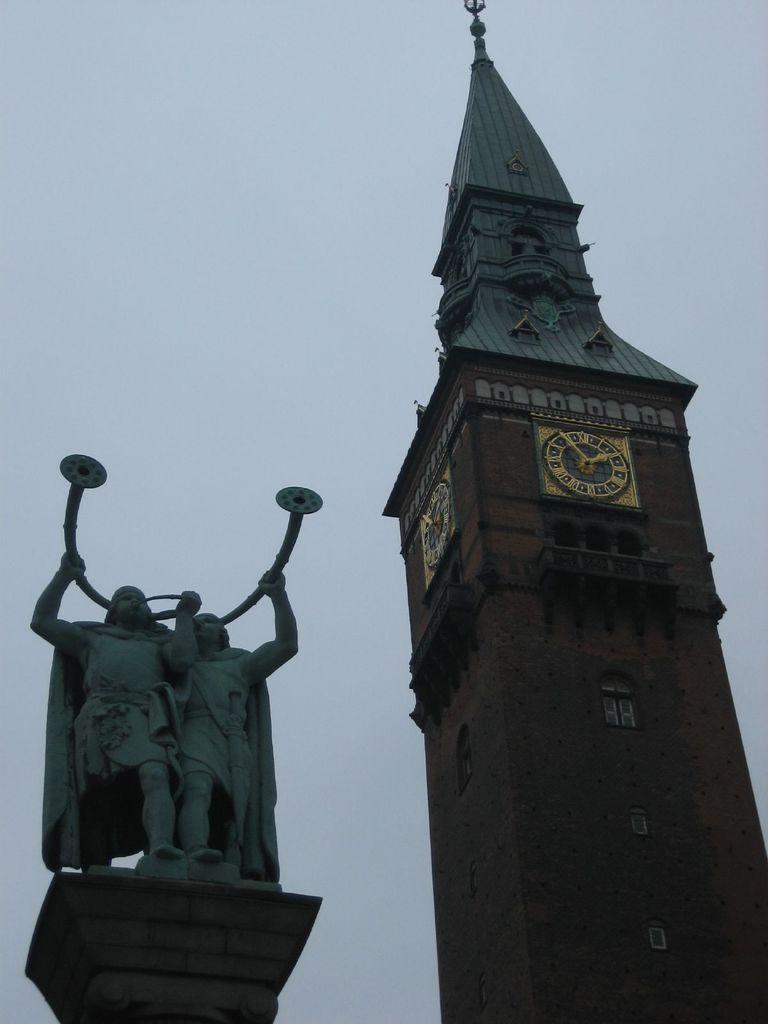Please provide a concise description of this image. This picture is clicked outside. On the right we can see the spire and we can see the clocks hanging on the walls of the spire and we can see the windows and the deck rails of the spire. On the left we can see the sculptures of two persons holding some objects and standing. In the background we can see the sky. 